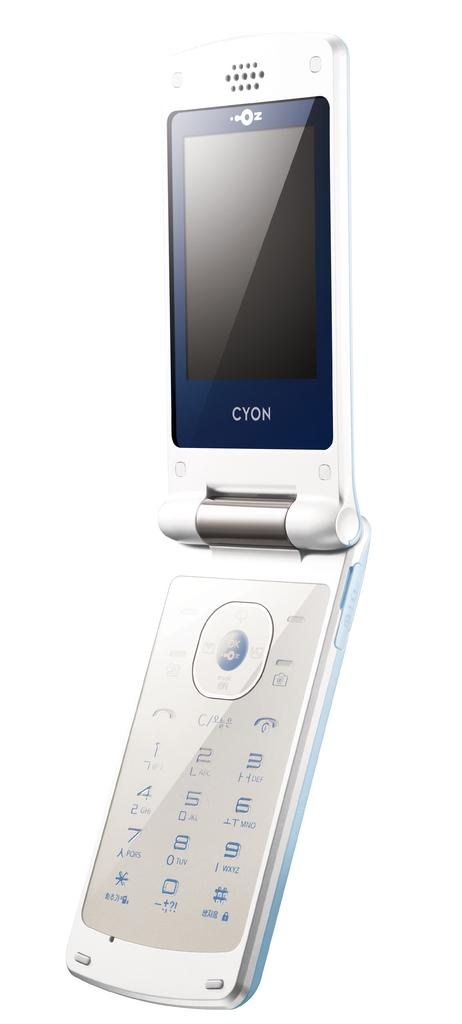What object is the main focus of the image? There is a mobile phone in the image. What color is the background of the image? The background of the image is white. What type of cable is connected to the mobile phone in the image? There is no cable connected to the mobile phone in the image. What type of food is being eaten with a fork in the image? There is no fork or food present in the image. 